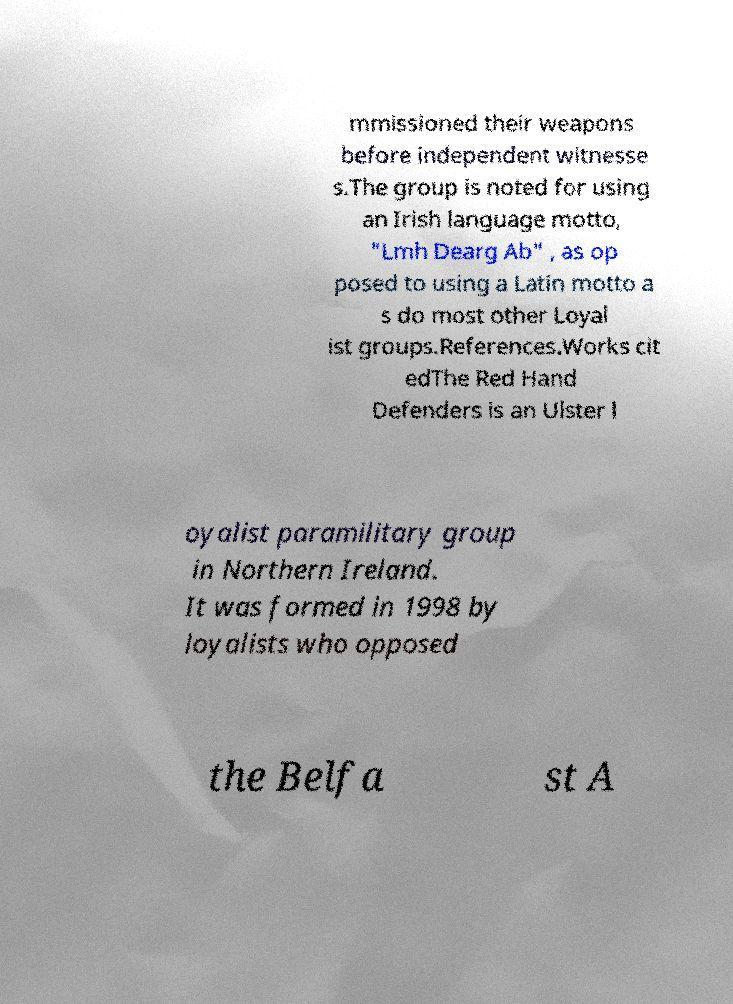Could you extract and type out the text from this image? mmissioned their weapons before independent witnesse s.The group is noted for using an Irish language motto, "Lmh Dearg Ab" , as op posed to using a Latin motto a s do most other Loyal ist groups.References.Works cit edThe Red Hand Defenders is an Ulster l oyalist paramilitary group in Northern Ireland. It was formed in 1998 by loyalists who opposed the Belfa st A 